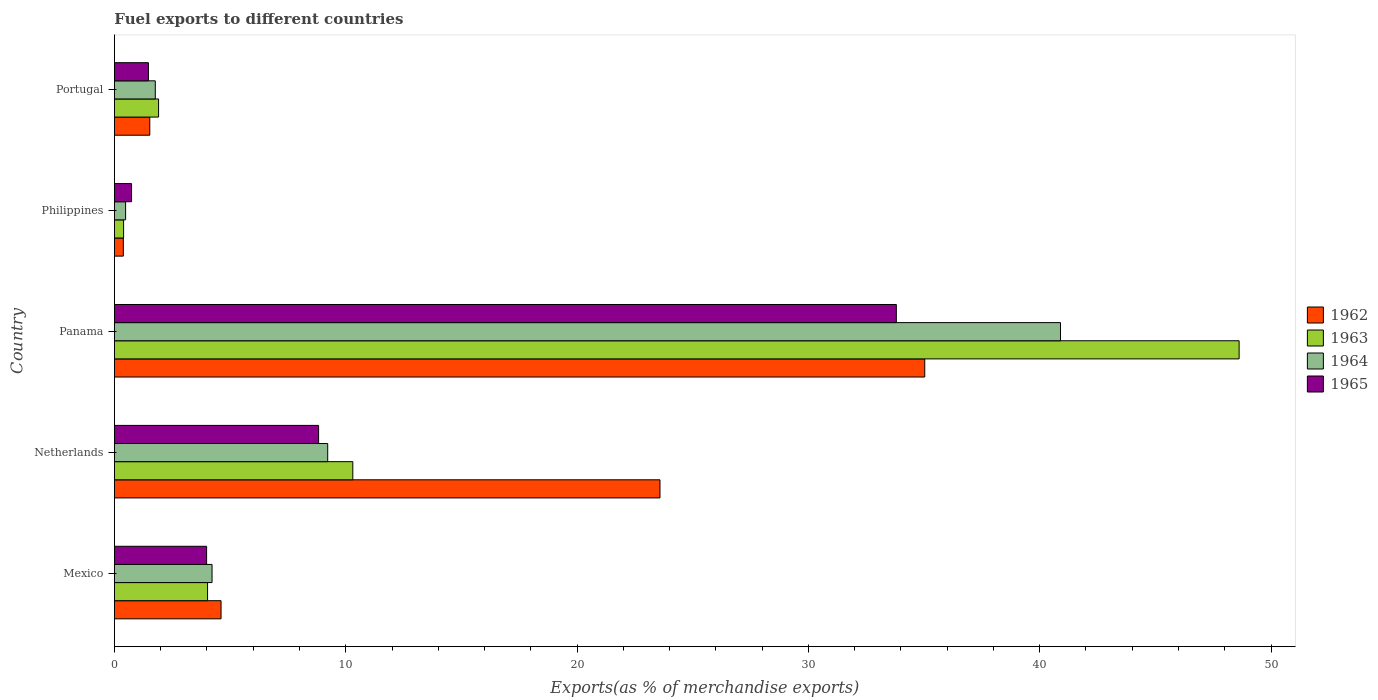How many different coloured bars are there?
Your answer should be very brief. 4. How many groups of bars are there?
Provide a short and direct response. 5. Are the number of bars per tick equal to the number of legend labels?
Make the answer very short. Yes. How many bars are there on the 2nd tick from the top?
Your answer should be compact. 4. What is the label of the 3rd group of bars from the top?
Make the answer very short. Panama. In how many cases, is the number of bars for a given country not equal to the number of legend labels?
Make the answer very short. 0. What is the percentage of exports to different countries in 1964 in Philippines?
Your answer should be very brief. 0.48. Across all countries, what is the maximum percentage of exports to different countries in 1962?
Keep it short and to the point. 35.03. Across all countries, what is the minimum percentage of exports to different countries in 1964?
Provide a succinct answer. 0.48. In which country was the percentage of exports to different countries in 1962 maximum?
Your answer should be very brief. Panama. What is the total percentage of exports to different countries in 1965 in the graph?
Your response must be concise. 48.82. What is the difference between the percentage of exports to different countries in 1962 in Netherlands and that in Philippines?
Give a very brief answer. 23.2. What is the difference between the percentage of exports to different countries in 1963 in Portugal and the percentage of exports to different countries in 1964 in Panama?
Ensure brevity in your answer.  -38.99. What is the average percentage of exports to different countries in 1965 per country?
Provide a short and direct response. 9.76. What is the difference between the percentage of exports to different countries in 1963 and percentage of exports to different countries in 1962 in Portugal?
Provide a succinct answer. 0.38. What is the ratio of the percentage of exports to different countries in 1962 in Mexico to that in Panama?
Provide a succinct answer. 0.13. Is the difference between the percentage of exports to different countries in 1963 in Philippines and Portugal greater than the difference between the percentage of exports to different countries in 1962 in Philippines and Portugal?
Your answer should be very brief. No. What is the difference between the highest and the second highest percentage of exports to different countries in 1964?
Your answer should be very brief. 31.68. What is the difference between the highest and the lowest percentage of exports to different countries in 1964?
Make the answer very short. 40.41. Is the sum of the percentage of exports to different countries in 1964 in Mexico and Netherlands greater than the maximum percentage of exports to different countries in 1965 across all countries?
Your answer should be very brief. No. Is it the case that in every country, the sum of the percentage of exports to different countries in 1963 and percentage of exports to different countries in 1965 is greater than the sum of percentage of exports to different countries in 1962 and percentage of exports to different countries in 1964?
Offer a terse response. No. What does the 1st bar from the top in Netherlands represents?
Provide a short and direct response. 1965. What does the 1st bar from the bottom in Portugal represents?
Make the answer very short. 1962. Are all the bars in the graph horizontal?
Give a very brief answer. Yes. How are the legend labels stacked?
Your answer should be compact. Vertical. What is the title of the graph?
Give a very brief answer. Fuel exports to different countries. What is the label or title of the X-axis?
Provide a short and direct response. Exports(as % of merchandise exports). What is the label or title of the Y-axis?
Keep it short and to the point. Country. What is the Exports(as % of merchandise exports) of 1962 in Mexico?
Your response must be concise. 4.61. What is the Exports(as % of merchandise exports) in 1963 in Mexico?
Offer a terse response. 4.03. What is the Exports(as % of merchandise exports) in 1964 in Mexico?
Provide a short and direct response. 4.22. What is the Exports(as % of merchandise exports) of 1965 in Mexico?
Ensure brevity in your answer.  3.99. What is the Exports(as % of merchandise exports) of 1962 in Netherlands?
Offer a very short reply. 23.58. What is the Exports(as % of merchandise exports) of 1963 in Netherlands?
Your answer should be compact. 10.31. What is the Exports(as % of merchandise exports) in 1964 in Netherlands?
Keep it short and to the point. 9.22. What is the Exports(as % of merchandise exports) of 1965 in Netherlands?
Provide a succinct answer. 8.83. What is the Exports(as % of merchandise exports) in 1962 in Panama?
Offer a terse response. 35.03. What is the Exports(as % of merchandise exports) in 1963 in Panama?
Provide a short and direct response. 48.62. What is the Exports(as % of merchandise exports) of 1964 in Panama?
Provide a short and direct response. 40.9. What is the Exports(as % of merchandise exports) of 1965 in Panama?
Keep it short and to the point. 33.8. What is the Exports(as % of merchandise exports) in 1962 in Philippines?
Your answer should be very brief. 0.38. What is the Exports(as % of merchandise exports) of 1963 in Philippines?
Offer a very short reply. 0.4. What is the Exports(as % of merchandise exports) of 1964 in Philippines?
Offer a very short reply. 0.48. What is the Exports(as % of merchandise exports) of 1965 in Philippines?
Your answer should be very brief. 0.74. What is the Exports(as % of merchandise exports) in 1962 in Portugal?
Offer a terse response. 1.53. What is the Exports(as % of merchandise exports) of 1963 in Portugal?
Make the answer very short. 1.91. What is the Exports(as % of merchandise exports) in 1964 in Portugal?
Offer a very short reply. 1.77. What is the Exports(as % of merchandise exports) of 1965 in Portugal?
Offer a very short reply. 1.47. Across all countries, what is the maximum Exports(as % of merchandise exports) in 1962?
Make the answer very short. 35.03. Across all countries, what is the maximum Exports(as % of merchandise exports) in 1963?
Provide a succinct answer. 48.62. Across all countries, what is the maximum Exports(as % of merchandise exports) in 1964?
Offer a very short reply. 40.9. Across all countries, what is the maximum Exports(as % of merchandise exports) in 1965?
Provide a short and direct response. 33.8. Across all countries, what is the minimum Exports(as % of merchandise exports) of 1962?
Make the answer very short. 0.38. Across all countries, what is the minimum Exports(as % of merchandise exports) of 1963?
Your answer should be compact. 0.4. Across all countries, what is the minimum Exports(as % of merchandise exports) of 1964?
Offer a very short reply. 0.48. Across all countries, what is the minimum Exports(as % of merchandise exports) of 1965?
Your answer should be compact. 0.74. What is the total Exports(as % of merchandise exports) in 1962 in the graph?
Your response must be concise. 65.14. What is the total Exports(as % of merchandise exports) of 1963 in the graph?
Offer a terse response. 65.26. What is the total Exports(as % of merchandise exports) in 1964 in the graph?
Your answer should be very brief. 56.59. What is the total Exports(as % of merchandise exports) of 1965 in the graph?
Ensure brevity in your answer.  48.82. What is the difference between the Exports(as % of merchandise exports) in 1962 in Mexico and that in Netherlands?
Give a very brief answer. -18.97. What is the difference between the Exports(as % of merchandise exports) in 1963 in Mexico and that in Netherlands?
Provide a succinct answer. -6.28. What is the difference between the Exports(as % of merchandise exports) of 1964 in Mexico and that in Netherlands?
Ensure brevity in your answer.  -5. What is the difference between the Exports(as % of merchandise exports) of 1965 in Mexico and that in Netherlands?
Keep it short and to the point. -4.84. What is the difference between the Exports(as % of merchandise exports) in 1962 in Mexico and that in Panama?
Provide a succinct answer. -30.42. What is the difference between the Exports(as % of merchandise exports) of 1963 in Mexico and that in Panama?
Keep it short and to the point. -44.59. What is the difference between the Exports(as % of merchandise exports) of 1964 in Mexico and that in Panama?
Your answer should be compact. -36.68. What is the difference between the Exports(as % of merchandise exports) of 1965 in Mexico and that in Panama?
Offer a terse response. -29.82. What is the difference between the Exports(as % of merchandise exports) in 1962 in Mexico and that in Philippines?
Ensure brevity in your answer.  4.22. What is the difference between the Exports(as % of merchandise exports) in 1963 in Mexico and that in Philippines?
Offer a very short reply. 3.63. What is the difference between the Exports(as % of merchandise exports) in 1964 in Mexico and that in Philippines?
Provide a succinct answer. 3.74. What is the difference between the Exports(as % of merchandise exports) of 1965 in Mexico and that in Philippines?
Provide a succinct answer. 3.25. What is the difference between the Exports(as % of merchandise exports) in 1962 in Mexico and that in Portugal?
Your answer should be compact. 3.08. What is the difference between the Exports(as % of merchandise exports) of 1963 in Mexico and that in Portugal?
Your answer should be compact. 2.12. What is the difference between the Exports(as % of merchandise exports) in 1964 in Mexico and that in Portugal?
Provide a short and direct response. 2.45. What is the difference between the Exports(as % of merchandise exports) of 1965 in Mexico and that in Portugal?
Make the answer very short. 2.52. What is the difference between the Exports(as % of merchandise exports) in 1962 in Netherlands and that in Panama?
Offer a very short reply. -11.45. What is the difference between the Exports(as % of merchandise exports) of 1963 in Netherlands and that in Panama?
Offer a terse response. -38.32. What is the difference between the Exports(as % of merchandise exports) in 1964 in Netherlands and that in Panama?
Offer a very short reply. -31.68. What is the difference between the Exports(as % of merchandise exports) in 1965 in Netherlands and that in Panama?
Provide a short and direct response. -24.98. What is the difference between the Exports(as % of merchandise exports) in 1962 in Netherlands and that in Philippines?
Give a very brief answer. 23.2. What is the difference between the Exports(as % of merchandise exports) of 1963 in Netherlands and that in Philippines?
Give a very brief answer. 9.91. What is the difference between the Exports(as % of merchandise exports) of 1964 in Netherlands and that in Philippines?
Your answer should be very brief. 8.74. What is the difference between the Exports(as % of merchandise exports) of 1965 in Netherlands and that in Philippines?
Your answer should be very brief. 8.09. What is the difference between the Exports(as % of merchandise exports) of 1962 in Netherlands and that in Portugal?
Provide a succinct answer. 22.06. What is the difference between the Exports(as % of merchandise exports) of 1963 in Netherlands and that in Portugal?
Your answer should be compact. 8.4. What is the difference between the Exports(as % of merchandise exports) of 1964 in Netherlands and that in Portugal?
Ensure brevity in your answer.  7.45. What is the difference between the Exports(as % of merchandise exports) in 1965 in Netherlands and that in Portugal?
Your response must be concise. 7.36. What is the difference between the Exports(as % of merchandise exports) in 1962 in Panama and that in Philippines?
Keep it short and to the point. 34.65. What is the difference between the Exports(as % of merchandise exports) of 1963 in Panama and that in Philippines?
Ensure brevity in your answer.  48.22. What is the difference between the Exports(as % of merchandise exports) of 1964 in Panama and that in Philippines?
Provide a succinct answer. 40.41. What is the difference between the Exports(as % of merchandise exports) of 1965 in Panama and that in Philippines?
Keep it short and to the point. 33.06. What is the difference between the Exports(as % of merchandise exports) in 1962 in Panama and that in Portugal?
Offer a very short reply. 33.5. What is the difference between the Exports(as % of merchandise exports) of 1963 in Panama and that in Portugal?
Provide a succinct answer. 46.71. What is the difference between the Exports(as % of merchandise exports) in 1964 in Panama and that in Portugal?
Offer a very short reply. 39.13. What is the difference between the Exports(as % of merchandise exports) in 1965 in Panama and that in Portugal?
Your answer should be compact. 32.33. What is the difference between the Exports(as % of merchandise exports) of 1962 in Philippines and that in Portugal?
Provide a short and direct response. -1.14. What is the difference between the Exports(as % of merchandise exports) of 1963 in Philippines and that in Portugal?
Provide a succinct answer. -1.51. What is the difference between the Exports(as % of merchandise exports) of 1964 in Philippines and that in Portugal?
Your answer should be compact. -1.28. What is the difference between the Exports(as % of merchandise exports) in 1965 in Philippines and that in Portugal?
Your answer should be very brief. -0.73. What is the difference between the Exports(as % of merchandise exports) of 1962 in Mexico and the Exports(as % of merchandise exports) of 1963 in Netherlands?
Provide a short and direct response. -5.7. What is the difference between the Exports(as % of merchandise exports) of 1962 in Mexico and the Exports(as % of merchandise exports) of 1964 in Netherlands?
Keep it short and to the point. -4.61. What is the difference between the Exports(as % of merchandise exports) in 1962 in Mexico and the Exports(as % of merchandise exports) in 1965 in Netherlands?
Your answer should be compact. -4.22. What is the difference between the Exports(as % of merchandise exports) in 1963 in Mexico and the Exports(as % of merchandise exports) in 1964 in Netherlands?
Your answer should be compact. -5.19. What is the difference between the Exports(as % of merchandise exports) of 1963 in Mexico and the Exports(as % of merchandise exports) of 1965 in Netherlands?
Your answer should be compact. -4.8. What is the difference between the Exports(as % of merchandise exports) of 1964 in Mexico and the Exports(as % of merchandise exports) of 1965 in Netherlands?
Offer a very short reply. -4.61. What is the difference between the Exports(as % of merchandise exports) of 1962 in Mexico and the Exports(as % of merchandise exports) of 1963 in Panama?
Provide a short and direct response. -44.01. What is the difference between the Exports(as % of merchandise exports) of 1962 in Mexico and the Exports(as % of merchandise exports) of 1964 in Panama?
Offer a very short reply. -36.29. What is the difference between the Exports(as % of merchandise exports) in 1962 in Mexico and the Exports(as % of merchandise exports) in 1965 in Panama?
Provide a short and direct response. -29.19. What is the difference between the Exports(as % of merchandise exports) in 1963 in Mexico and the Exports(as % of merchandise exports) in 1964 in Panama?
Your response must be concise. -36.87. What is the difference between the Exports(as % of merchandise exports) in 1963 in Mexico and the Exports(as % of merchandise exports) in 1965 in Panama?
Keep it short and to the point. -29.78. What is the difference between the Exports(as % of merchandise exports) in 1964 in Mexico and the Exports(as % of merchandise exports) in 1965 in Panama?
Give a very brief answer. -29.58. What is the difference between the Exports(as % of merchandise exports) of 1962 in Mexico and the Exports(as % of merchandise exports) of 1963 in Philippines?
Your answer should be compact. 4.21. What is the difference between the Exports(as % of merchandise exports) in 1962 in Mexico and the Exports(as % of merchandise exports) in 1964 in Philippines?
Your response must be concise. 4.13. What is the difference between the Exports(as % of merchandise exports) of 1962 in Mexico and the Exports(as % of merchandise exports) of 1965 in Philippines?
Your response must be concise. 3.87. What is the difference between the Exports(as % of merchandise exports) in 1963 in Mexico and the Exports(as % of merchandise exports) in 1964 in Philippines?
Your answer should be compact. 3.54. What is the difference between the Exports(as % of merchandise exports) of 1963 in Mexico and the Exports(as % of merchandise exports) of 1965 in Philippines?
Your response must be concise. 3.29. What is the difference between the Exports(as % of merchandise exports) of 1964 in Mexico and the Exports(as % of merchandise exports) of 1965 in Philippines?
Your answer should be very brief. 3.48. What is the difference between the Exports(as % of merchandise exports) in 1962 in Mexico and the Exports(as % of merchandise exports) in 1963 in Portugal?
Your answer should be compact. 2.7. What is the difference between the Exports(as % of merchandise exports) in 1962 in Mexico and the Exports(as % of merchandise exports) in 1964 in Portugal?
Make the answer very short. 2.84. What is the difference between the Exports(as % of merchandise exports) of 1962 in Mexico and the Exports(as % of merchandise exports) of 1965 in Portugal?
Provide a short and direct response. 3.14. What is the difference between the Exports(as % of merchandise exports) in 1963 in Mexico and the Exports(as % of merchandise exports) in 1964 in Portugal?
Offer a terse response. 2.26. What is the difference between the Exports(as % of merchandise exports) of 1963 in Mexico and the Exports(as % of merchandise exports) of 1965 in Portugal?
Your answer should be very brief. 2.56. What is the difference between the Exports(as % of merchandise exports) in 1964 in Mexico and the Exports(as % of merchandise exports) in 1965 in Portugal?
Your response must be concise. 2.75. What is the difference between the Exports(as % of merchandise exports) in 1962 in Netherlands and the Exports(as % of merchandise exports) in 1963 in Panama?
Provide a succinct answer. -25.04. What is the difference between the Exports(as % of merchandise exports) in 1962 in Netherlands and the Exports(as % of merchandise exports) in 1964 in Panama?
Your response must be concise. -17.31. What is the difference between the Exports(as % of merchandise exports) in 1962 in Netherlands and the Exports(as % of merchandise exports) in 1965 in Panama?
Provide a succinct answer. -10.22. What is the difference between the Exports(as % of merchandise exports) in 1963 in Netherlands and the Exports(as % of merchandise exports) in 1964 in Panama?
Your response must be concise. -30.59. What is the difference between the Exports(as % of merchandise exports) of 1963 in Netherlands and the Exports(as % of merchandise exports) of 1965 in Panama?
Give a very brief answer. -23.5. What is the difference between the Exports(as % of merchandise exports) in 1964 in Netherlands and the Exports(as % of merchandise exports) in 1965 in Panama?
Ensure brevity in your answer.  -24.58. What is the difference between the Exports(as % of merchandise exports) of 1962 in Netherlands and the Exports(as % of merchandise exports) of 1963 in Philippines?
Provide a short and direct response. 23.19. What is the difference between the Exports(as % of merchandise exports) of 1962 in Netherlands and the Exports(as % of merchandise exports) of 1964 in Philippines?
Provide a succinct answer. 23.1. What is the difference between the Exports(as % of merchandise exports) of 1962 in Netherlands and the Exports(as % of merchandise exports) of 1965 in Philippines?
Keep it short and to the point. 22.84. What is the difference between the Exports(as % of merchandise exports) of 1963 in Netherlands and the Exports(as % of merchandise exports) of 1964 in Philippines?
Provide a short and direct response. 9.82. What is the difference between the Exports(as % of merchandise exports) of 1963 in Netherlands and the Exports(as % of merchandise exports) of 1965 in Philippines?
Provide a short and direct response. 9.57. What is the difference between the Exports(as % of merchandise exports) of 1964 in Netherlands and the Exports(as % of merchandise exports) of 1965 in Philippines?
Keep it short and to the point. 8.48. What is the difference between the Exports(as % of merchandise exports) of 1962 in Netherlands and the Exports(as % of merchandise exports) of 1963 in Portugal?
Give a very brief answer. 21.68. What is the difference between the Exports(as % of merchandise exports) in 1962 in Netherlands and the Exports(as % of merchandise exports) in 1964 in Portugal?
Give a very brief answer. 21.82. What is the difference between the Exports(as % of merchandise exports) in 1962 in Netherlands and the Exports(as % of merchandise exports) in 1965 in Portugal?
Offer a terse response. 22.11. What is the difference between the Exports(as % of merchandise exports) of 1963 in Netherlands and the Exports(as % of merchandise exports) of 1964 in Portugal?
Provide a short and direct response. 8.54. What is the difference between the Exports(as % of merchandise exports) in 1963 in Netherlands and the Exports(as % of merchandise exports) in 1965 in Portugal?
Offer a terse response. 8.84. What is the difference between the Exports(as % of merchandise exports) of 1964 in Netherlands and the Exports(as % of merchandise exports) of 1965 in Portugal?
Offer a terse response. 7.75. What is the difference between the Exports(as % of merchandise exports) of 1962 in Panama and the Exports(as % of merchandise exports) of 1963 in Philippines?
Provide a succinct answer. 34.63. What is the difference between the Exports(as % of merchandise exports) in 1962 in Panama and the Exports(as % of merchandise exports) in 1964 in Philippines?
Offer a very short reply. 34.55. What is the difference between the Exports(as % of merchandise exports) of 1962 in Panama and the Exports(as % of merchandise exports) of 1965 in Philippines?
Your answer should be very brief. 34.29. What is the difference between the Exports(as % of merchandise exports) of 1963 in Panama and the Exports(as % of merchandise exports) of 1964 in Philippines?
Your answer should be compact. 48.14. What is the difference between the Exports(as % of merchandise exports) in 1963 in Panama and the Exports(as % of merchandise exports) in 1965 in Philippines?
Offer a very short reply. 47.88. What is the difference between the Exports(as % of merchandise exports) of 1964 in Panama and the Exports(as % of merchandise exports) of 1965 in Philippines?
Make the answer very short. 40.16. What is the difference between the Exports(as % of merchandise exports) in 1962 in Panama and the Exports(as % of merchandise exports) in 1963 in Portugal?
Keep it short and to the point. 33.12. What is the difference between the Exports(as % of merchandise exports) in 1962 in Panama and the Exports(as % of merchandise exports) in 1964 in Portugal?
Provide a succinct answer. 33.26. What is the difference between the Exports(as % of merchandise exports) of 1962 in Panama and the Exports(as % of merchandise exports) of 1965 in Portugal?
Your answer should be compact. 33.56. What is the difference between the Exports(as % of merchandise exports) in 1963 in Panama and the Exports(as % of merchandise exports) in 1964 in Portugal?
Offer a terse response. 46.85. What is the difference between the Exports(as % of merchandise exports) in 1963 in Panama and the Exports(as % of merchandise exports) in 1965 in Portugal?
Keep it short and to the point. 47.15. What is the difference between the Exports(as % of merchandise exports) in 1964 in Panama and the Exports(as % of merchandise exports) in 1965 in Portugal?
Provide a succinct answer. 39.43. What is the difference between the Exports(as % of merchandise exports) of 1962 in Philippines and the Exports(as % of merchandise exports) of 1963 in Portugal?
Your response must be concise. -1.52. What is the difference between the Exports(as % of merchandise exports) of 1962 in Philippines and the Exports(as % of merchandise exports) of 1964 in Portugal?
Your answer should be compact. -1.38. What is the difference between the Exports(as % of merchandise exports) of 1962 in Philippines and the Exports(as % of merchandise exports) of 1965 in Portugal?
Provide a short and direct response. -1.08. What is the difference between the Exports(as % of merchandise exports) of 1963 in Philippines and the Exports(as % of merchandise exports) of 1964 in Portugal?
Ensure brevity in your answer.  -1.37. What is the difference between the Exports(as % of merchandise exports) in 1963 in Philippines and the Exports(as % of merchandise exports) in 1965 in Portugal?
Offer a very short reply. -1.07. What is the difference between the Exports(as % of merchandise exports) of 1964 in Philippines and the Exports(as % of merchandise exports) of 1965 in Portugal?
Provide a short and direct response. -0.99. What is the average Exports(as % of merchandise exports) of 1962 per country?
Ensure brevity in your answer.  13.03. What is the average Exports(as % of merchandise exports) in 1963 per country?
Provide a short and direct response. 13.05. What is the average Exports(as % of merchandise exports) of 1964 per country?
Ensure brevity in your answer.  11.32. What is the average Exports(as % of merchandise exports) of 1965 per country?
Provide a short and direct response. 9.76. What is the difference between the Exports(as % of merchandise exports) in 1962 and Exports(as % of merchandise exports) in 1963 in Mexico?
Your response must be concise. 0.58. What is the difference between the Exports(as % of merchandise exports) of 1962 and Exports(as % of merchandise exports) of 1964 in Mexico?
Your answer should be compact. 0.39. What is the difference between the Exports(as % of merchandise exports) in 1962 and Exports(as % of merchandise exports) in 1965 in Mexico?
Ensure brevity in your answer.  0.62. What is the difference between the Exports(as % of merchandise exports) in 1963 and Exports(as % of merchandise exports) in 1964 in Mexico?
Ensure brevity in your answer.  -0.19. What is the difference between the Exports(as % of merchandise exports) in 1963 and Exports(as % of merchandise exports) in 1965 in Mexico?
Keep it short and to the point. 0.04. What is the difference between the Exports(as % of merchandise exports) of 1964 and Exports(as % of merchandise exports) of 1965 in Mexico?
Your answer should be compact. 0.23. What is the difference between the Exports(as % of merchandise exports) of 1962 and Exports(as % of merchandise exports) of 1963 in Netherlands?
Make the answer very short. 13.28. What is the difference between the Exports(as % of merchandise exports) of 1962 and Exports(as % of merchandise exports) of 1964 in Netherlands?
Provide a succinct answer. 14.36. What is the difference between the Exports(as % of merchandise exports) of 1962 and Exports(as % of merchandise exports) of 1965 in Netherlands?
Offer a terse response. 14.76. What is the difference between the Exports(as % of merchandise exports) of 1963 and Exports(as % of merchandise exports) of 1964 in Netherlands?
Provide a short and direct response. 1.09. What is the difference between the Exports(as % of merchandise exports) in 1963 and Exports(as % of merchandise exports) in 1965 in Netherlands?
Provide a succinct answer. 1.48. What is the difference between the Exports(as % of merchandise exports) of 1964 and Exports(as % of merchandise exports) of 1965 in Netherlands?
Provide a short and direct response. 0.39. What is the difference between the Exports(as % of merchandise exports) of 1962 and Exports(as % of merchandise exports) of 1963 in Panama?
Give a very brief answer. -13.59. What is the difference between the Exports(as % of merchandise exports) in 1962 and Exports(as % of merchandise exports) in 1964 in Panama?
Your response must be concise. -5.87. What is the difference between the Exports(as % of merchandise exports) in 1962 and Exports(as % of merchandise exports) in 1965 in Panama?
Your answer should be compact. 1.23. What is the difference between the Exports(as % of merchandise exports) in 1963 and Exports(as % of merchandise exports) in 1964 in Panama?
Offer a terse response. 7.72. What is the difference between the Exports(as % of merchandise exports) of 1963 and Exports(as % of merchandise exports) of 1965 in Panama?
Keep it short and to the point. 14.82. What is the difference between the Exports(as % of merchandise exports) in 1964 and Exports(as % of merchandise exports) in 1965 in Panama?
Your answer should be compact. 7.1. What is the difference between the Exports(as % of merchandise exports) in 1962 and Exports(as % of merchandise exports) in 1963 in Philippines?
Give a very brief answer. -0.01. What is the difference between the Exports(as % of merchandise exports) in 1962 and Exports(as % of merchandise exports) in 1964 in Philippines?
Provide a short and direct response. -0.1. What is the difference between the Exports(as % of merchandise exports) of 1962 and Exports(as % of merchandise exports) of 1965 in Philippines?
Your response must be concise. -0.35. What is the difference between the Exports(as % of merchandise exports) in 1963 and Exports(as % of merchandise exports) in 1964 in Philippines?
Give a very brief answer. -0.09. What is the difference between the Exports(as % of merchandise exports) of 1963 and Exports(as % of merchandise exports) of 1965 in Philippines?
Provide a succinct answer. -0.34. What is the difference between the Exports(as % of merchandise exports) in 1964 and Exports(as % of merchandise exports) in 1965 in Philippines?
Provide a succinct answer. -0.26. What is the difference between the Exports(as % of merchandise exports) of 1962 and Exports(as % of merchandise exports) of 1963 in Portugal?
Your response must be concise. -0.38. What is the difference between the Exports(as % of merchandise exports) in 1962 and Exports(as % of merchandise exports) in 1964 in Portugal?
Ensure brevity in your answer.  -0.24. What is the difference between the Exports(as % of merchandise exports) of 1962 and Exports(as % of merchandise exports) of 1965 in Portugal?
Your answer should be very brief. 0.06. What is the difference between the Exports(as % of merchandise exports) of 1963 and Exports(as % of merchandise exports) of 1964 in Portugal?
Keep it short and to the point. 0.14. What is the difference between the Exports(as % of merchandise exports) in 1963 and Exports(as % of merchandise exports) in 1965 in Portugal?
Your response must be concise. 0.44. What is the difference between the Exports(as % of merchandise exports) of 1964 and Exports(as % of merchandise exports) of 1965 in Portugal?
Offer a very short reply. 0.3. What is the ratio of the Exports(as % of merchandise exports) of 1962 in Mexico to that in Netherlands?
Offer a terse response. 0.2. What is the ratio of the Exports(as % of merchandise exports) in 1963 in Mexico to that in Netherlands?
Give a very brief answer. 0.39. What is the ratio of the Exports(as % of merchandise exports) of 1964 in Mexico to that in Netherlands?
Provide a succinct answer. 0.46. What is the ratio of the Exports(as % of merchandise exports) of 1965 in Mexico to that in Netherlands?
Offer a terse response. 0.45. What is the ratio of the Exports(as % of merchandise exports) of 1962 in Mexico to that in Panama?
Offer a terse response. 0.13. What is the ratio of the Exports(as % of merchandise exports) of 1963 in Mexico to that in Panama?
Your answer should be compact. 0.08. What is the ratio of the Exports(as % of merchandise exports) of 1964 in Mexico to that in Panama?
Offer a terse response. 0.1. What is the ratio of the Exports(as % of merchandise exports) in 1965 in Mexico to that in Panama?
Offer a terse response. 0.12. What is the ratio of the Exports(as % of merchandise exports) of 1962 in Mexico to that in Philippines?
Provide a short and direct response. 11.97. What is the ratio of the Exports(as % of merchandise exports) of 1963 in Mexico to that in Philippines?
Your answer should be very brief. 10.17. What is the ratio of the Exports(as % of merchandise exports) of 1964 in Mexico to that in Philippines?
Ensure brevity in your answer.  8.73. What is the ratio of the Exports(as % of merchandise exports) of 1965 in Mexico to that in Philippines?
Keep it short and to the point. 5.39. What is the ratio of the Exports(as % of merchandise exports) of 1962 in Mexico to that in Portugal?
Your response must be concise. 3.02. What is the ratio of the Exports(as % of merchandise exports) of 1963 in Mexico to that in Portugal?
Your answer should be very brief. 2.11. What is the ratio of the Exports(as % of merchandise exports) in 1964 in Mexico to that in Portugal?
Ensure brevity in your answer.  2.39. What is the ratio of the Exports(as % of merchandise exports) in 1965 in Mexico to that in Portugal?
Your answer should be very brief. 2.71. What is the ratio of the Exports(as % of merchandise exports) of 1962 in Netherlands to that in Panama?
Provide a short and direct response. 0.67. What is the ratio of the Exports(as % of merchandise exports) of 1963 in Netherlands to that in Panama?
Ensure brevity in your answer.  0.21. What is the ratio of the Exports(as % of merchandise exports) of 1964 in Netherlands to that in Panama?
Your answer should be very brief. 0.23. What is the ratio of the Exports(as % of merchandise exports) of 1965 in Netherlands to that in Panama?
Ensure brevity in your answer.  0.26. What is the ratio of the Exports(as % of merchandise exports) of 1962 in Netherlands to that in Philippines?
Offer a very short reply. 61.27. What is the ratio of the Exports(as % of merchandise exports) in 1963 in Netherlands to that in Philippines?
Make the answer very short. 26.03. What is the ratio of the Exports(as % of merchandise exports) of 1964 in Netherlands to that in Philippines?
Your answer should be compact. 19.07. What is the ratio of the Exports(as % of merchandise exports) of 1965 in Netherlands to that in Philippines?
Your answer should be very brief. 11.93. What is the ratio of the Exports(as % of merchandise exports) in 1962 in Netherlands to that in Portugal?
Offer a terse response. 15.43. What is the ratio of the Exports(as % of merchandise exports) of 1963 in Netherlands to that in Portugal?
Make the answer very short. 5.4. What is the ratio of the Exports(as % of merchandise exports) of 1964 in Netherlands to that in Portugal?
Make the answer very short. 5.22. What is the ratio of the Exports(as % of merchandise exports) in 1965 in Netherlands to that in Portugal?
Your response must be concise. 6.01. What is the ratio of the Exports(as % of merchandise exports) of 1962 in Panama to that in Philippines?
Provide a short and direct response. 91.01. What is the ratio of the Exports(as % of merchandise exports) of 1963 in Panama to that in Philippines?
Make the answer very short. 122.82. What is the ratio of the Exports(as % of merchandise exports) of 1964 in Panama to that in Philippines?
Give a very brief answer. 84.6. What is the ratio of the Exports(as % of merchandise exports) of 1965 in Panama to that in Philippines?
Ensure brevity in your answer.  45.69. What is the ratio of the Exports(as % of merchandise exports) of 1962 in Panama to that in Portugal?
Give a very brief answer. 22.92. What is the ratio of the Exports(as % of merchandise exports) of 1963 in Panama to that in Portugal?
Your response must be concise. 25.47. What is the ratio of the Exports(as % of merchandise exports) in 1964 in Panama to that in Portugal?
Provide a succinct answer. 23.15. What is the ratio of the Exports(as % of merchandise exports) of 1965 in Panama to that in Portugal?
Make the answer very short. 23. What is the ratio of the Exports(as % of merchandise exports) of 1962 in Philippines to that in Portugal?
Make the answer very short. 0.25. What is the ratio of the Exports(as % of merchandise exports) in 1963 in Philippines to that in Portugal?
Your answer should be very brief. 0.21. What is the ratio of the Exports(as % of merchandise exports) in 1964 in Philippines to that in Portugal?
Provide a short and direct response. 0.27. What is the ratio of the Exports(as % of merchandise exports) of 1965 in Philippines to that in Portugal?
Ensure brevity in your answer.  0.5. What is the difference between the highest and the second highest Exports(as % of merchandise exports) of 1962?
Keep it short and to the point. 11.45. What is the difference between the highest and the second highest Exports(as % of merchandise exports) in 1963?
Provide a succinct answer. 38.32. What is the difference between the highest and the second highest Exports(as % of merchandise exports) in 1964?
Ensure brevity in your answer.  31.68. What is the difference between the highest and the second highest Exports(as % of merchandise exports) of 1965?
Ensure brevity in your answer.  24.98. What is the difference between the highest and the lowest Exports(as % of merchandise exports) of 1962?
Provide a short and direct response. 34.65. What is the difference between the highest and the lowest Exports(as % of merchandise exports) of 1963?
Provide a short and direct response. 48.22. What is the difference between the highest and the lowest Exports(as % of merchandise exports) in 1964?
Your answer should be very brief. 40.41. What is the difference between the highest and the lowest Exports(as % of merchandise exports) of 1965?
Offer a terse response. 33.06. 